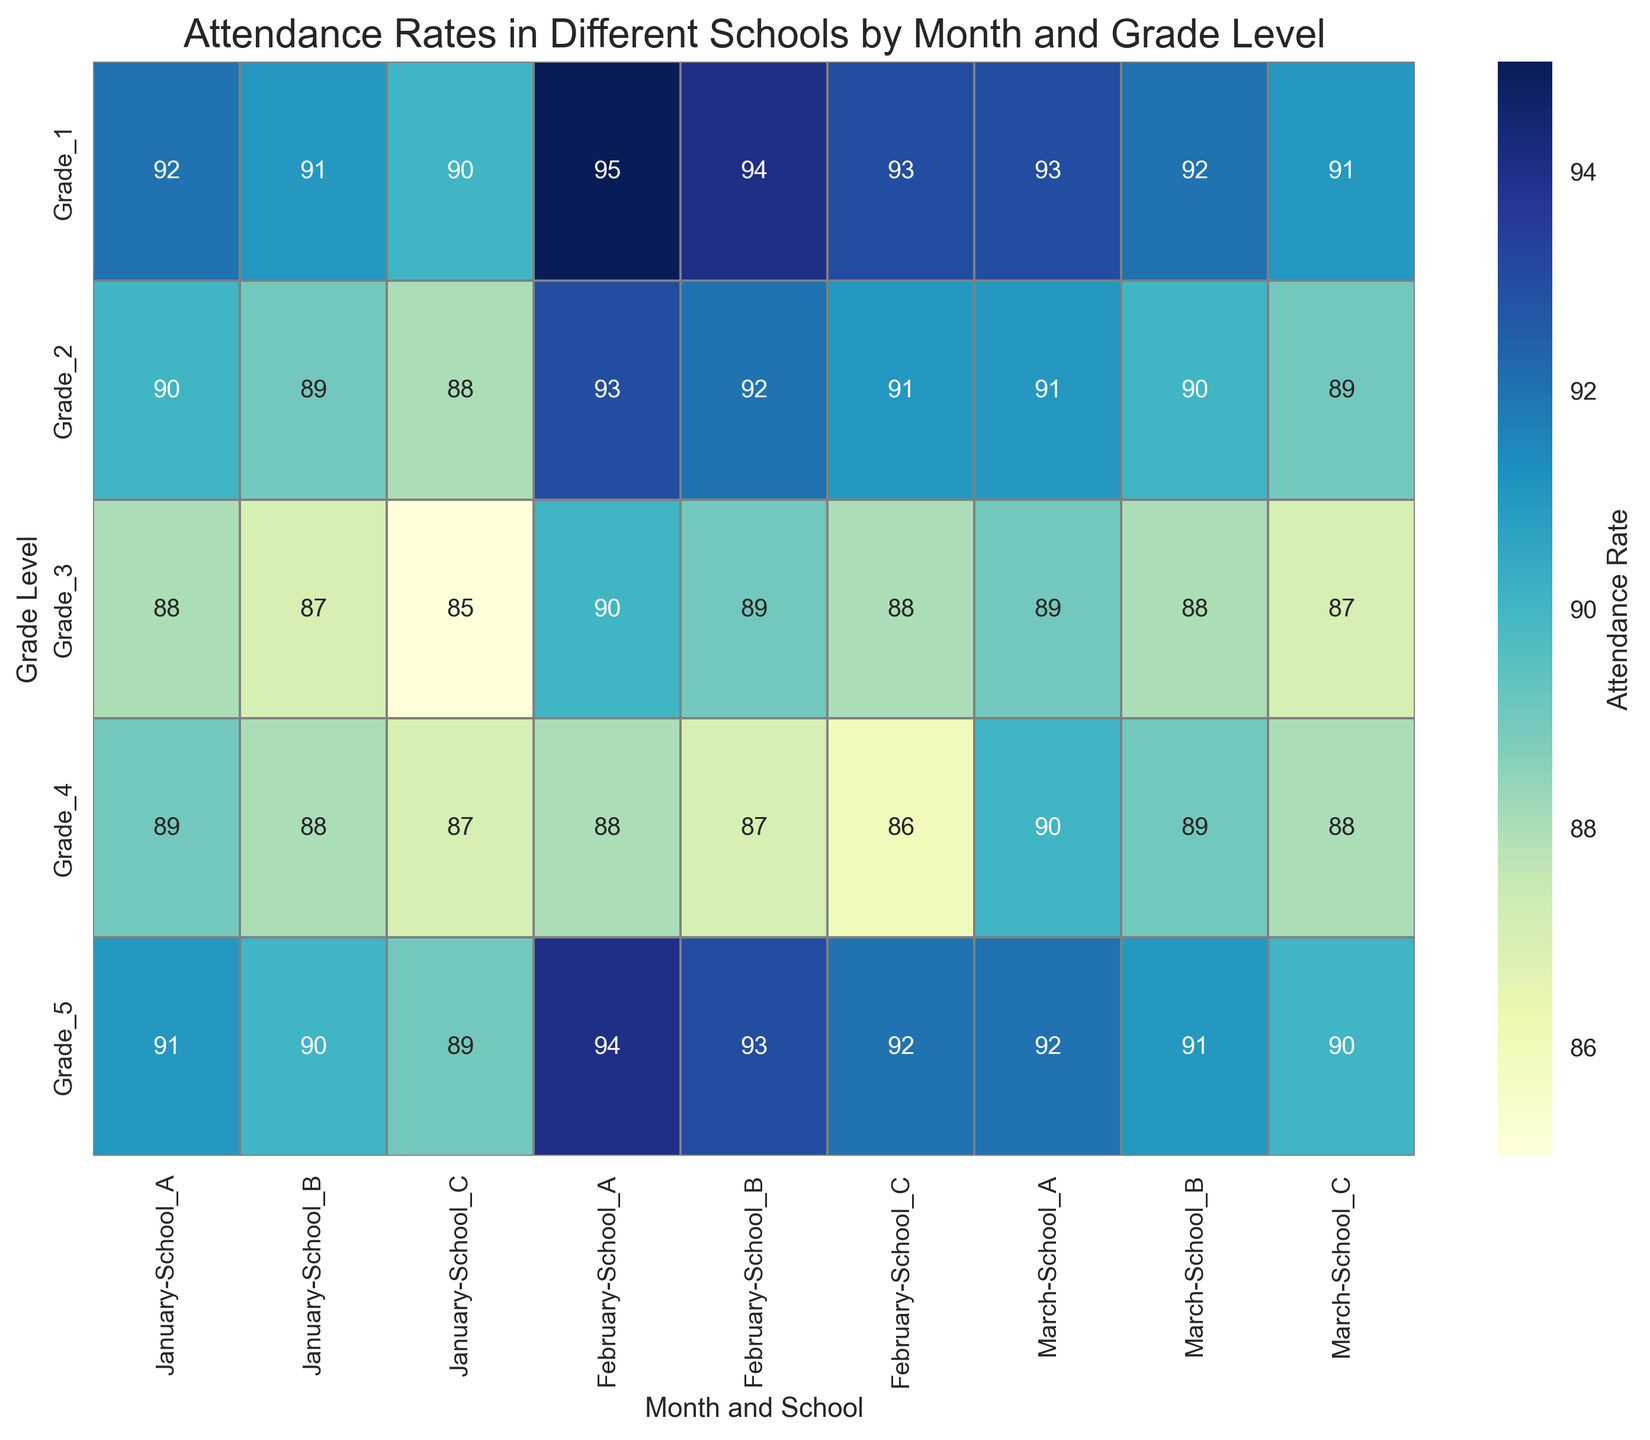What is the attendance rate of Grade 1 in School A during March? Refer to the cell where Grade 1 intersects with March under School A. The attendance rate is 93.
Answer: 93 Which school has the highest attendance rate for Grade 3 in January? Compare the attendance rates of Grade 3 for each school in January. School A has 88, School B has 87, and School C has 85. School A has the highest rate.
Answer: School A In February, which grade in School B shows the lowest attendance rate? Look at the February column for School B and find the minimum value. Grade 4 has the lowest attendance rate of 87.
Answer: Grade 4 How does the attendance rate of Grade 5 in School C change from January to March? Compare the attendance rates of Grade 5 in School C across January (89), February (92), and March (90). Calculate the change: January to February (+3), February to March (-2).
Answer: +3, -2 What is the average attendance rate for Grade 2 across all schools in February? Find the attendance rates of Grade 2 in February for all schools: School A (93), School B (92), School C (91). Calculate the average: (93+92+91)/3 = 276/3 = 92.
Answer: 92 Which school has the least variation in attendance rates across all grades in March? Evaluate the attendance rates across all grades in March for each school. Calculate the range (max - min) for each school: 
School A: max (93) - min (89) = 4 
School B: max (92) - min (88) = 4
School C: max (91) - min (87) = 4. All schools have the same variation.
Answer: All schools Which month shows the highest overall attendance rate in School C? Compute the average attendance rate for each month in School C: 
January: (90+88+85+87+89)/5 = 87.8 
February: (93+91+88+86+92)/5 = 90 
March: (91+89+87+88+90)/5 = 89. 
February has the highest average attendance rate.
Answer: February How does the attendance rate for Grade 4 in School B compare between January and February? Compare the attendance rates of Grade 4 in School B between January (88) and February (87). There is a decrease of 1 percentage point.
Answer: Decrease by 1 What is the difference between the highest and lowest attendance rates in School A for March? Identify the highest and lowest attendance rates in School A for March: Highest is 93 (Grade 1), and lowest is 89 (Grade 3). Calculate the difference: 93 - 89 = 4.
Answer: 4 